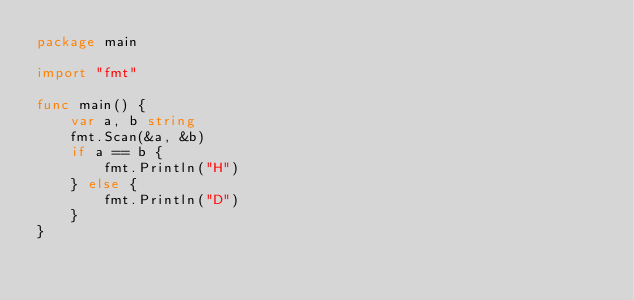Convert code to text. <code><loc_0><loc_0><loc_500><loc_500><_Go_>package main

import "fmt"

func main() {
	var a, b string
	fmt.Scan(&a, &b)
	if a == b {
		fmt.Println("H")
	} else {
		fmt.Println("D")
	}
}</code> 